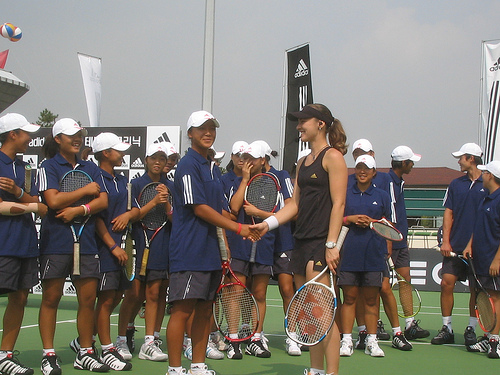<image>
Can you confirm if the black girl is to the left of the blue girl? No. The black girl is not to the left of the blue girl. From this viewpoint, they have a different horizontal relationship. Is there a flag behind the girl? Yes. From this viewpoint, the flag is positioned behind the girl, with the girl partially or fully occluding the flag. 